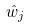<formula> <loc_0><loc_0><loc_500><loc_500>\hat { w } _ { j }</formula> 